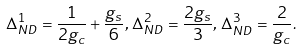Convert formula to latex. <formula><loc_0><loc_0><loc_500><loc_500>\Delta _ { N D } ^ { 1 } = \frac { 1 } { 2 g _ { c } } + \frac { g _ { s } } { 6 } , \, \Delta _ { N D } ^ { 2 } = \frac { 2 g _ { s } } { 3 } , \, \Delta _ { N D } ^ { 3 } = \frac { 2 } { g _ { c } } .</formula> 